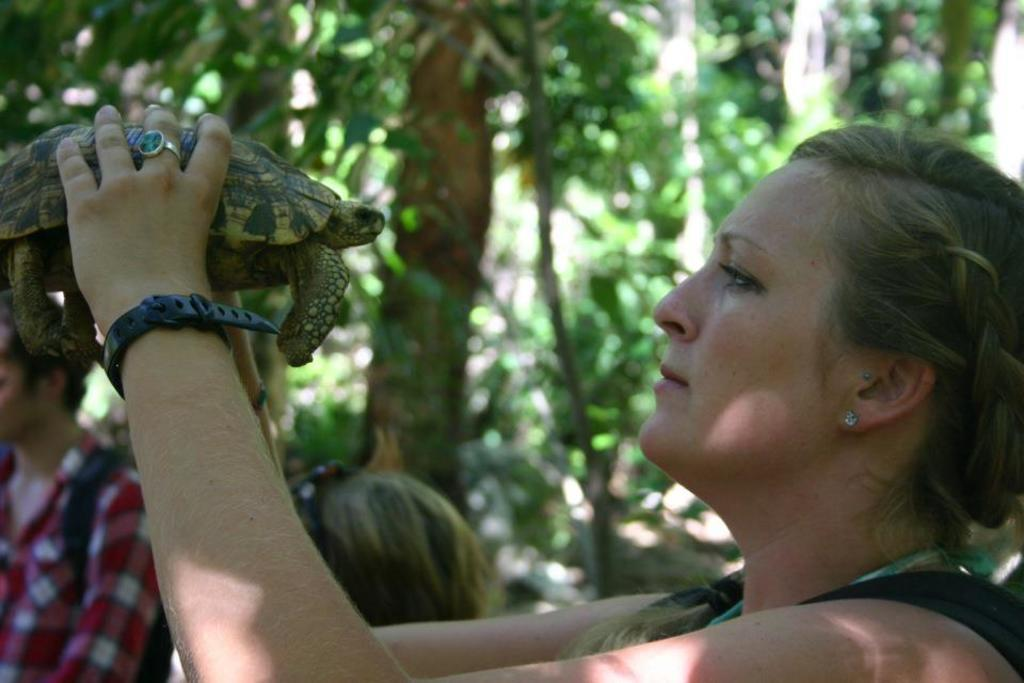Where is the woman located in the image? The woman is in the right corner of the image. What is the woman holding in the image? The woman is holding a tortoise. Are there any other people in the image? Yes, there are people beside the woman. What can be seen in the background of the image? There are trees in the background of the image. What color is the woman's eye in the image? The facts provided do not mention the color of the woman's eye, so it cannot be determined from the image. 